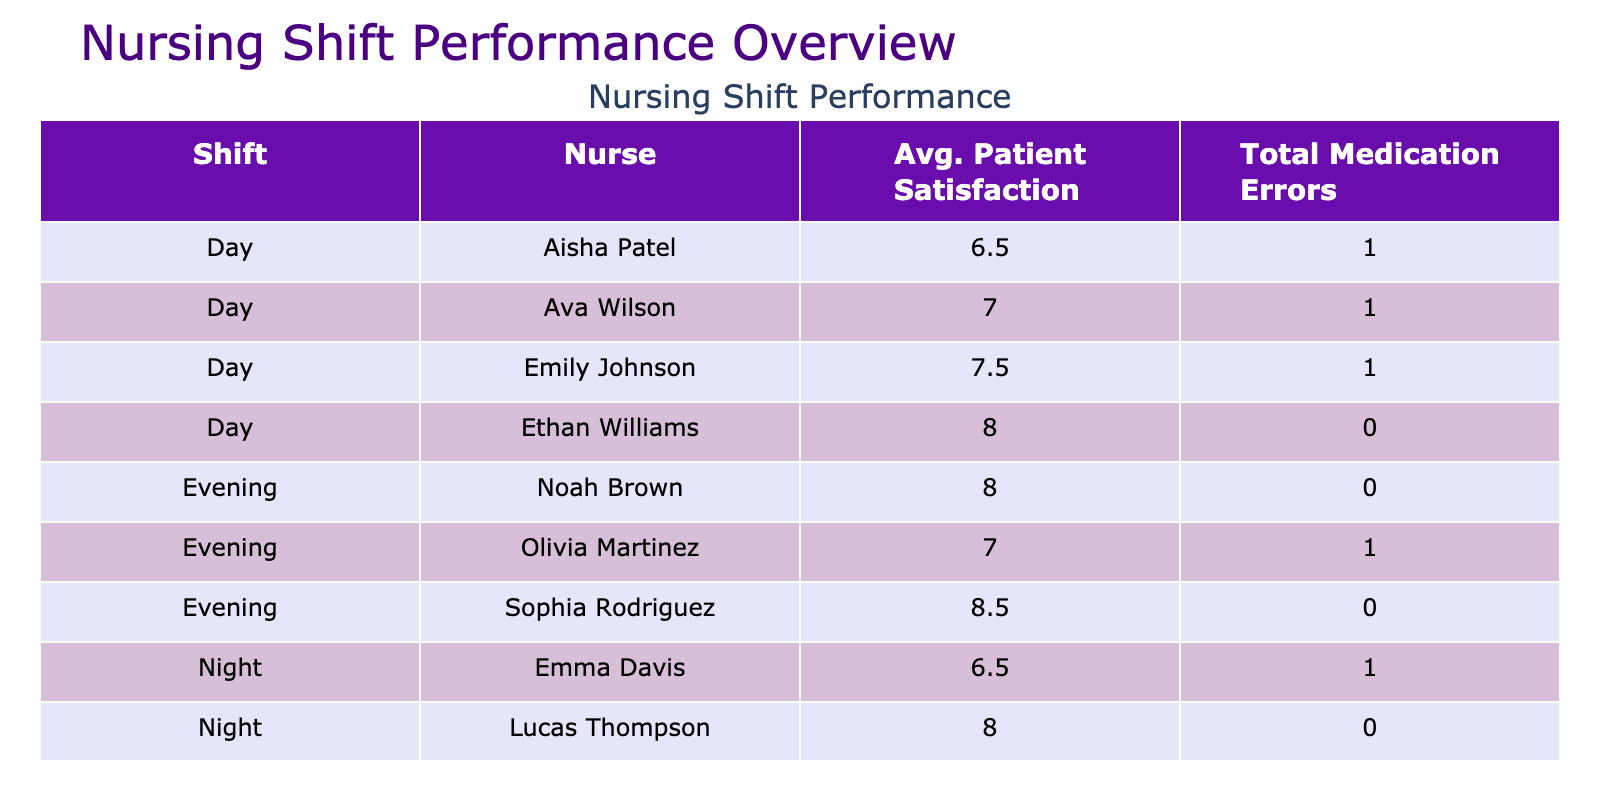What is the average patient satisfaction for nurses working the night shift? There are four nurses on the night shift: Michael Chen (7.5), Emma Davis (8), and Lucas Thompson (8). The average patient satisfaction is calculated by summing 7.5 + 8 + 8 = 23.5 and dividing it by the number of nurses, which is 4. Therefore, the average satisfaction is 23.5 / 4 = 7.88.
Answer: 7.88 Which nurse had the highest total medication errors? Looking at the medication errors for each nurse, Aisha Patel and Olivia Martinez each have one error. The nurse with the highest total medication errors is Aisha Patel and Olivia Martinez with one each.
Answer: Aisha Patel and Olivia Martinez What is the total number of medication errors across all shifts? The total medication errors can be found by summing all individual errors from the table. The individual errors are 0, 1, 0, 0, 0, 0, 1, 0, 0, 0, 1, 0, 0, 1, 0, 0, 0, and the total is 0 + 1 + 0 + 0 + 0 + 0 + 1 + 0 + 0 + 0 + 1 + 0 + 0 + 1 + 0 + 0 + 0 = 5.
Answer: 5 Is the patient satisfaction higher on day shifts compared to evening shifts? On the day shift, the average patient satisfaction is (8 + 7 + 5 + 8 + 9) / 5 = 7.4, while on the evening shift, it is (8 + 9 + 6 + 8) / 4 = 7.75. Since 7.75 is greater than 7.4, patient satisfaction is indeed higher on evening shifts than day shifts.
Answer: No Which nurse achieved the best patient outcome (most improved patients) during the different shifts? By examining the care outcomes, Emily Johnson and Sophia Rodriguez each achieved 3 improved cases and the best patient outcome.
Answer: Emily Johnson and Sophia Rodriguez 